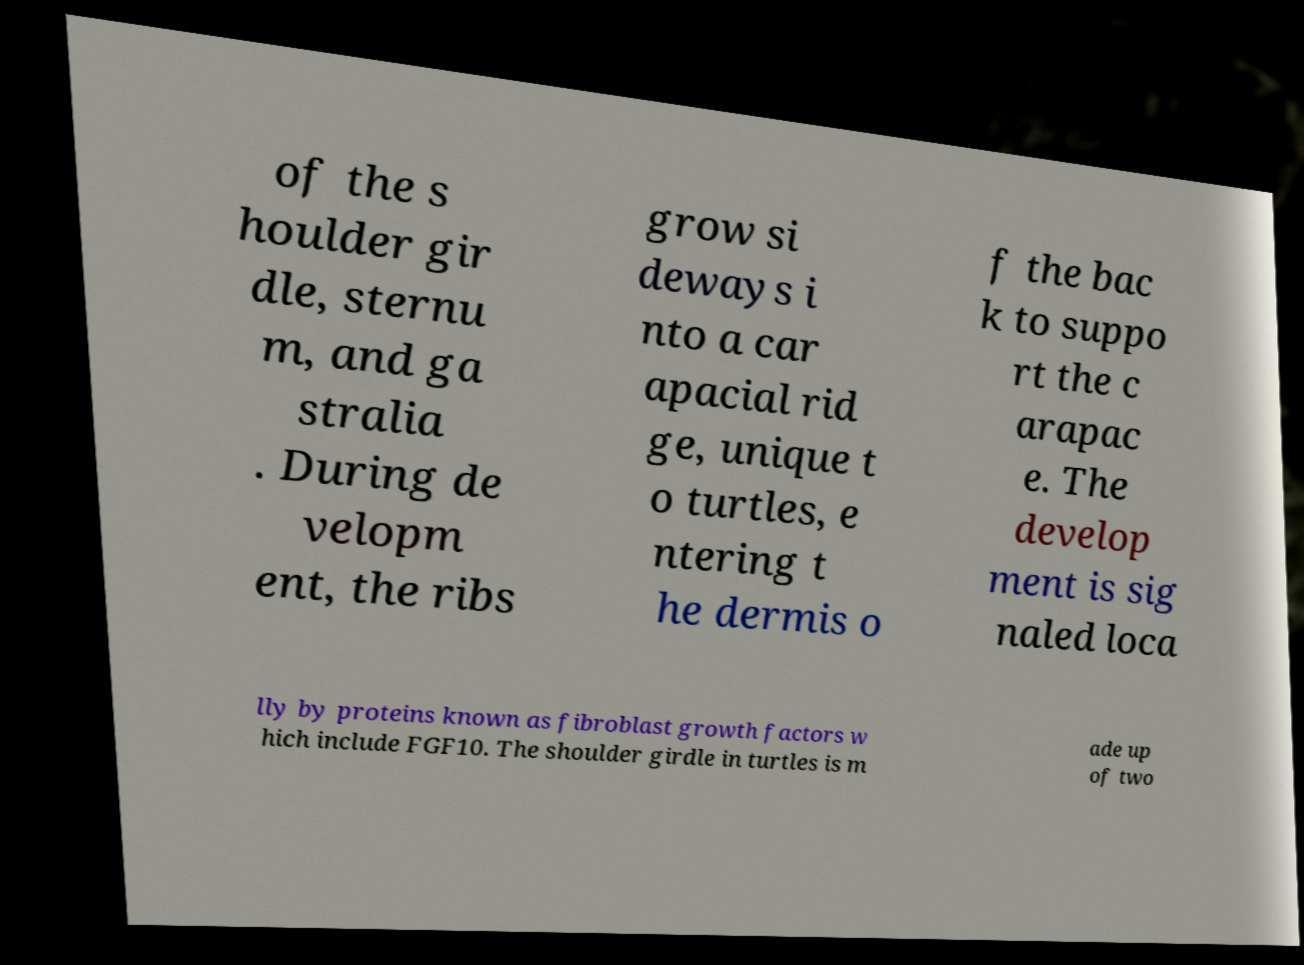What messages or text are displayed in this image? I need them in a readable, typed format. of the s houlder gir dle, sternu m, and ga stralia . During de velopm ent, the ribs grow si deways i nto a car apacial rid ge, unique t o turtles, e ntering t he dermis o f the bac k to suppo rt the c arapac e. The develop ment is sig naled loca lly by proteins known as fibroblast growth factors w hich include FGF10. The shoulder girdle in turtles is m ade up of two 